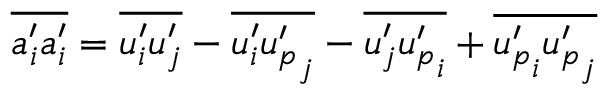Convert formula to latex. <formula><loc_0><loc_0><loc_500><loc_500>\overline { { a _ { i } ^ { \prime } a _ { i } ^ { \prime } } } = \overline { { u _ { i } ^ { \prime } u _ { j } ^ { \prime } } } - \overline { { u _ { i } ^ { \prime } { u _ { p } ^ { \prime } } _ { j } } } - \overline { { u _ { j } ^ { \prime } { u _ { p } ^ { \prime } } _ { i } } } + \overline { { { u _ { p } ^ { \prime } } _ { i } { u _ { p } ^ { \prime } } _ { j } } }</formula> 